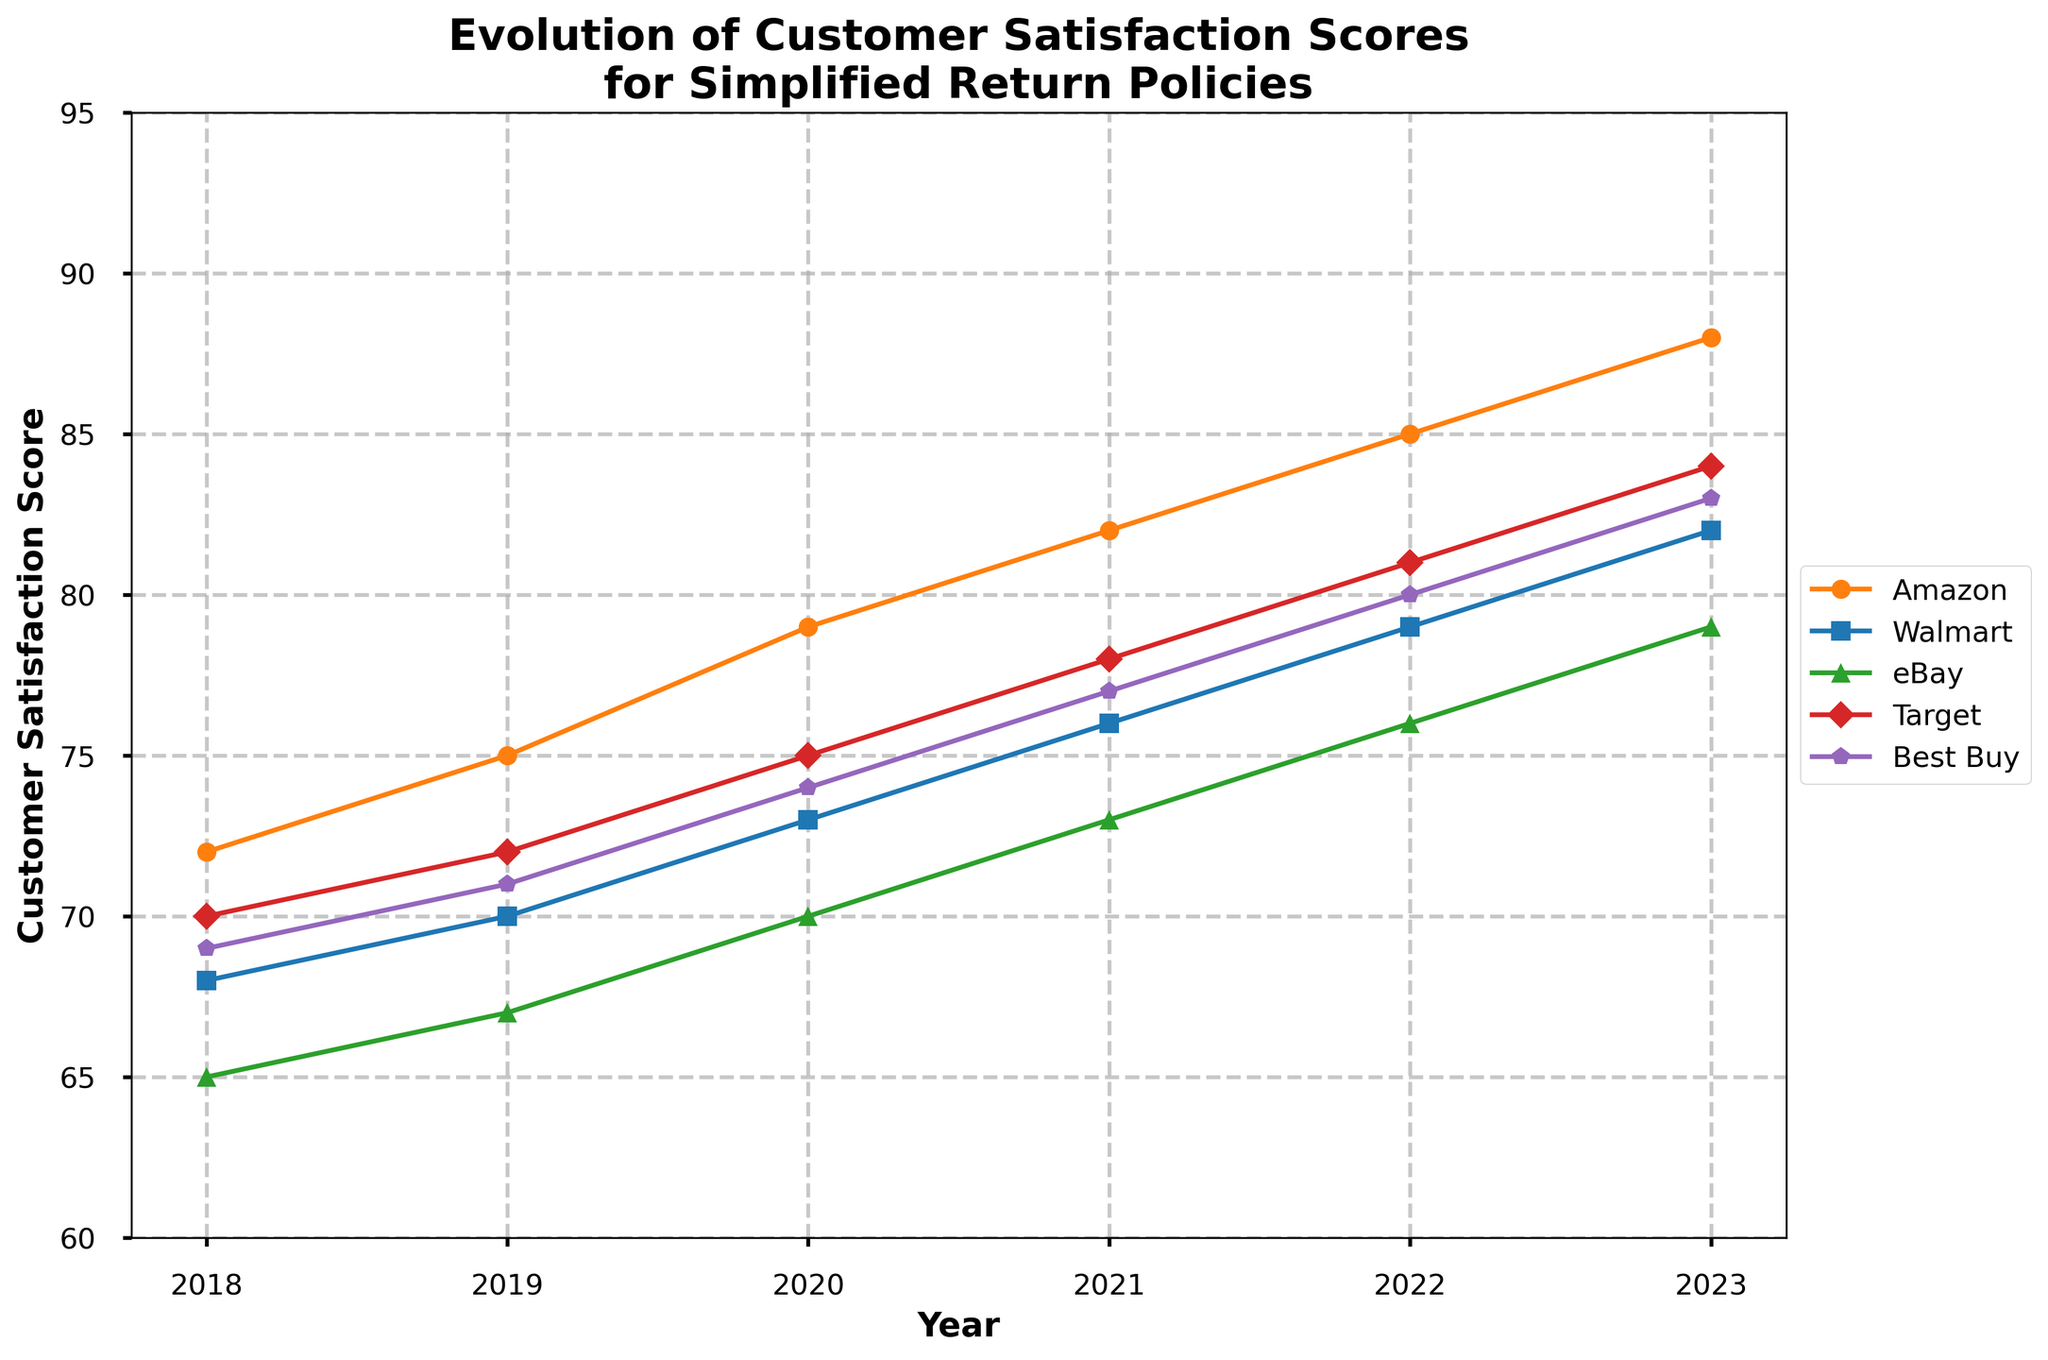Which retailer had the highest customer satisfaction score in 2023? Look at the 2023 data points for each retailer. The highest score is for Amazon with a score of 88.
Answer: Amazon Which year did Target surpass Walmart in customer satisfaction score? Compare Target's and Walmart's data points from each year. In 2021, Target (78) surpassed Walmart (76).
Answer: 2021 By how much did eBay's customer satisfaction score increase from 2018 to 2023? Subtract eBay's score in 2018 from its score in 2023: 79 - 65 = 14.
Answer: 14 Calculate the average customer satisfaction score for all the retailers in 2020. Add up the scores for all retailers in 2020: (79 + 73 + 70 + 75 + 74) = 371, then divide by 5 (number of retailers): 371 / 5 = 74.2.
Answer: 74.2 Which retailer showed the most consistent improvement in customer satisfaction score over the years? Check the trend lines; Amazon shows a consistent, uninterrupted increase each year from 72 in 2018 to 88 in 2023.
Answer: Amazon Compare the improvement in customer satisfaction scores from 2018 to 2023 for Walmart and Best Buy. Who improved more, and by how much? Walmart improved from 68 in 2018 to 82 in 2023 (82 - 68 = 14), and Best Buy improved from 69 in 2018 to 83 in 2023 (83 - 69 = 14). Both improved by 14 points.
Answer: Both by 14 points In which year did Amazon first exceed a customer satisfaction score of 80? Check Amazon's data points year by year. Amazon first exceeded 80 in 2021 with a score of 82.
Answer: 2021 Which retailer had the lowest customer satisfaction score in 2018, and what was the score? Look at the 2018 data points for each retailer; the lowest score is for eBay with a score of 65.
Answer: eBay, 65 What is the difference in customer satisfaction scores between Target and Best Buy in 2022? Subtract Best Buy's 2022 score from Target's 2022 score: 81 - 80 = 1.
Answer: 1 